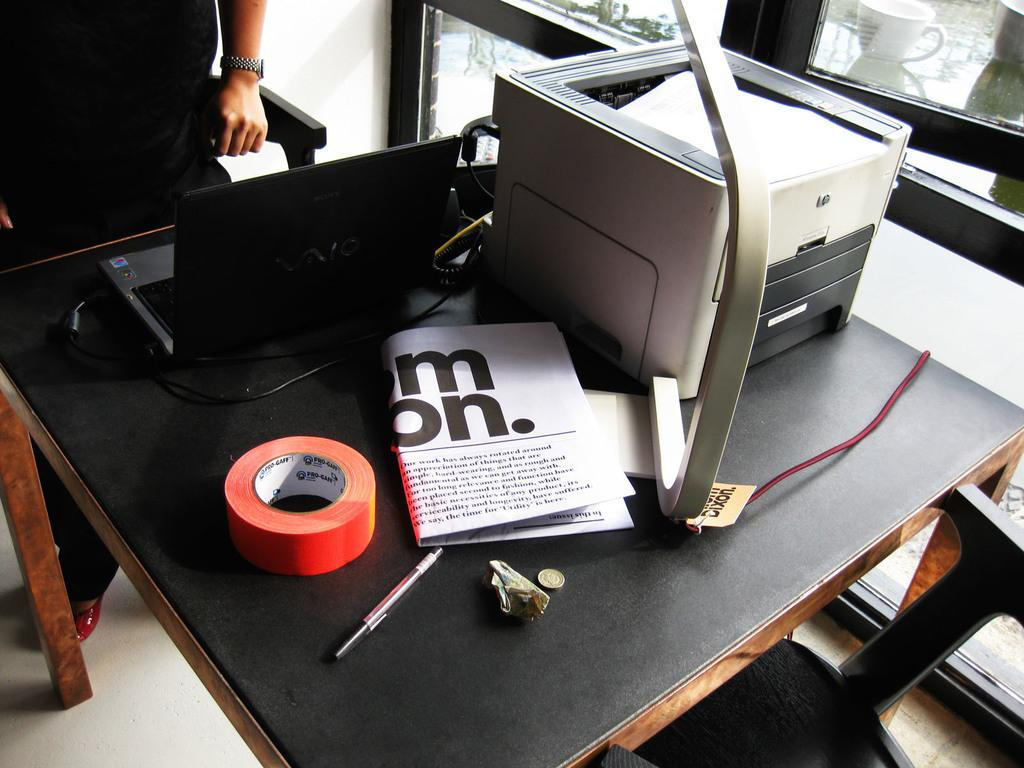What is on the table in the image? There is a printer, a laptop, tape, a pen, a coin, and paper on the table. What is the person standing beside the table doing? The person's actions are not visible in the image. What type of seating is available in the image? There is a chair in the image. What can be seen through the window in the image? A cup is visible outside the window. What suggestion does the fireman make in the image? There is no fireman present in the image, so no suggestion can be attributed to them. What is on the back of the person standing beside the table? The image does not show the back of the person standing beside the table, so it cannot be determined what is on their back. 